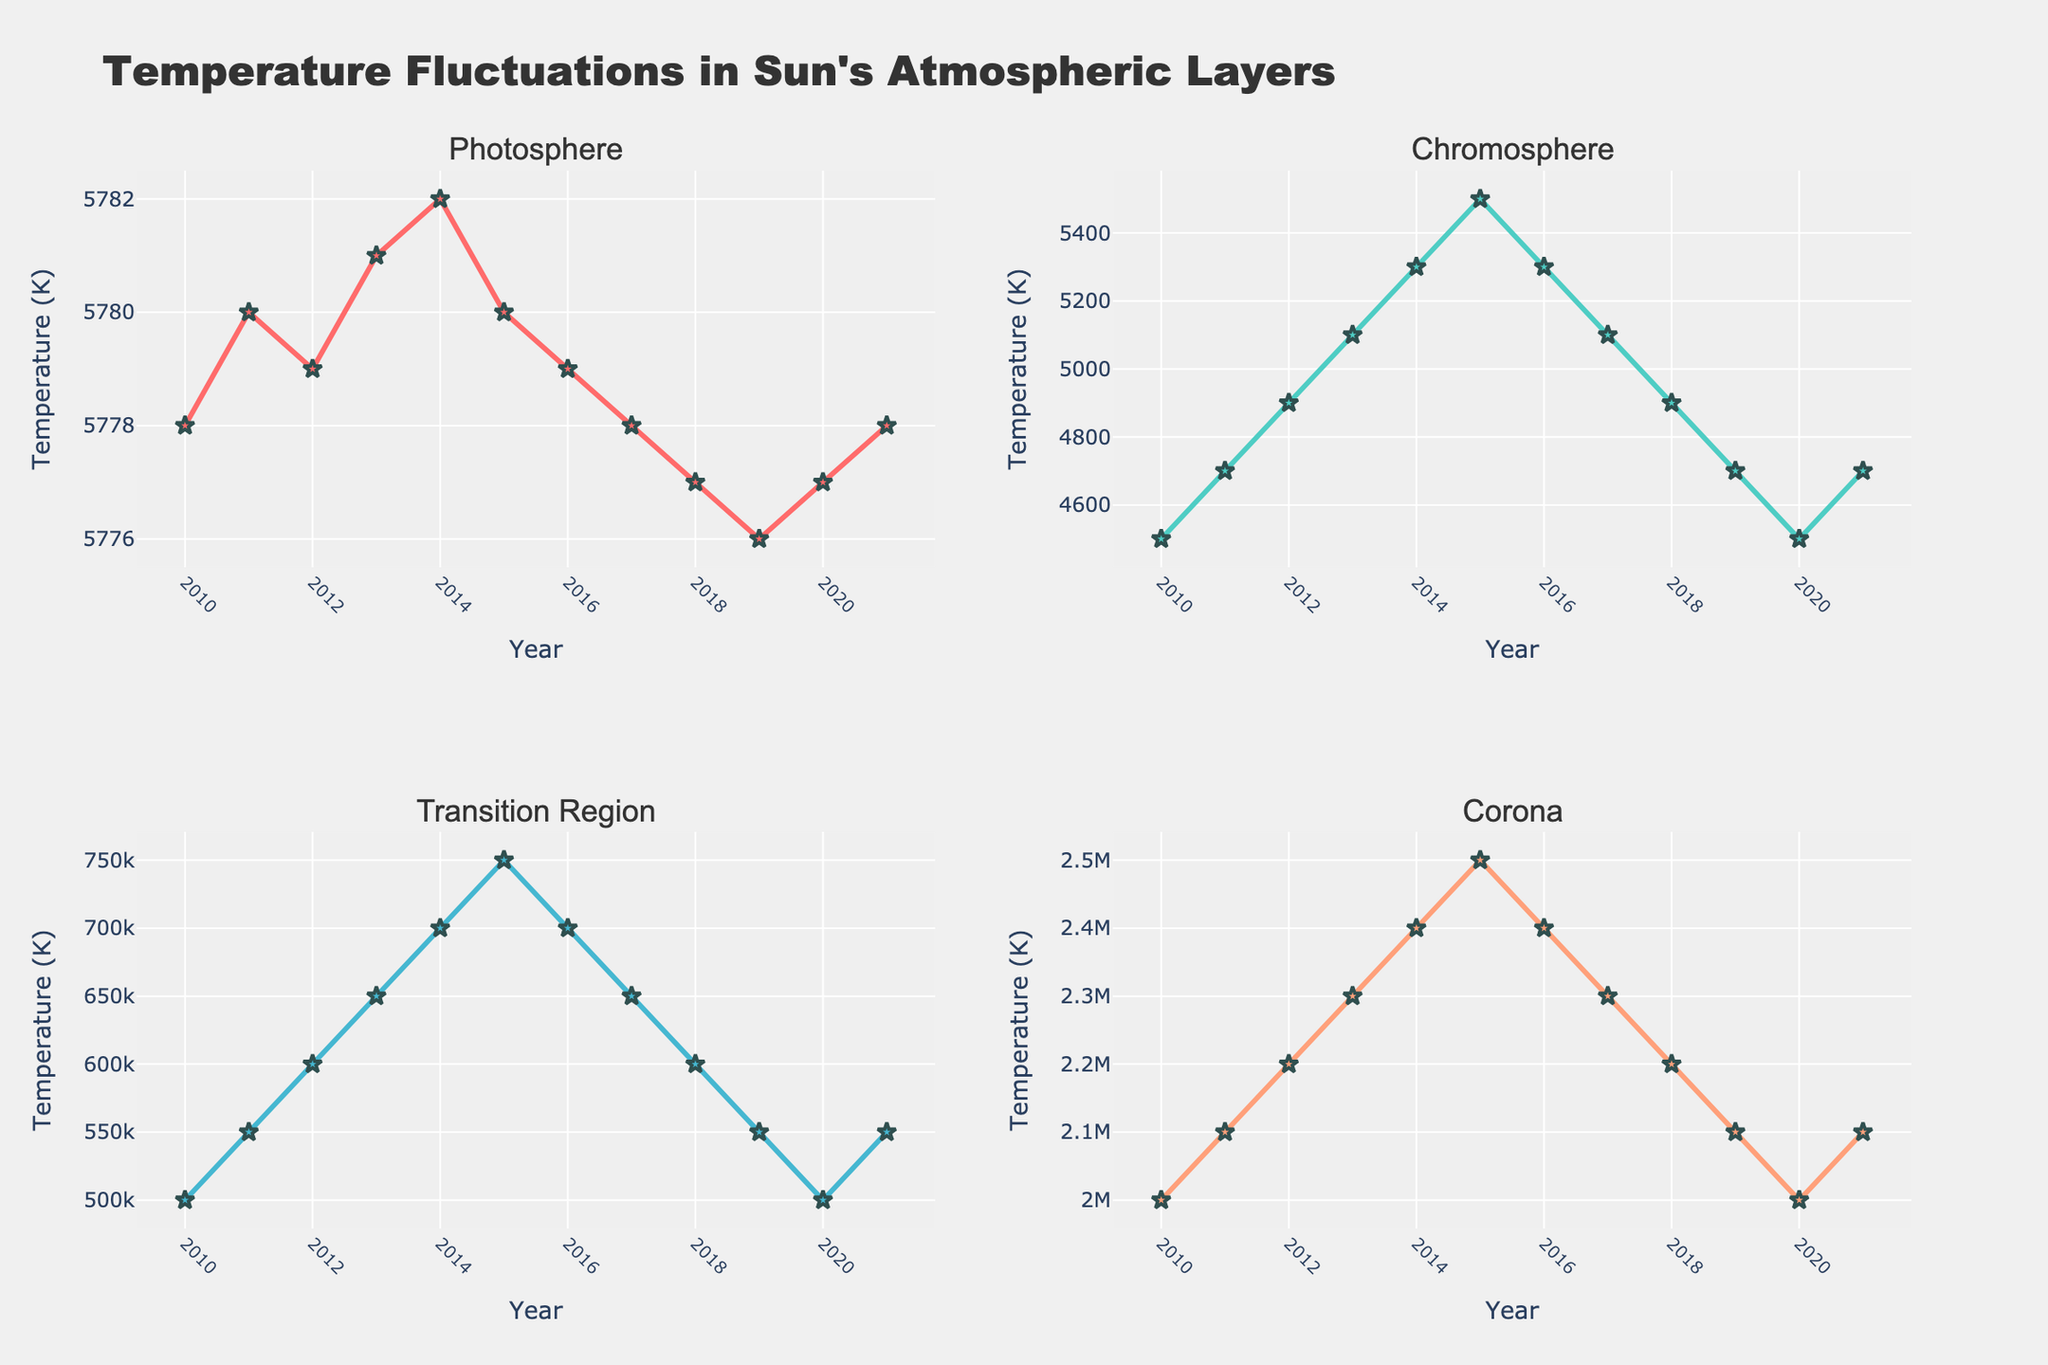what is the title of the figure? The title of the figure can be found at the top. It is written in larger text and serves as the header for the entire figure.
Answer: Temperature Fluctuations in Sun's Atmospheric Layers What is the temperature in the Photosphere in the year 2014? Look at the subplot titled "Photosphere". Find the point on the line marked for 2014. Read the corresponding temperature value.
Answer: 5782 K Which layer shows the highest temperature in the year 2016? Observe all subplots for the year 2016. Compare the temperature values. The highest temperature is in the Corona subplot.
Answer: Corona What is the temperature difference between the Chromosphere and the Transition Region in the year 2020? Locate 2020 in both the Chromosphere and Transition Region subplots. Subtract the Chromosphere temperature from the Transition Region temperature (500000 - 4500).
Answer: 495500 K Which layer has the smallest temperature range over the years? Compare the temperature fluctuations visually across all subplots. The Photosphere appears to have the smallest temperature range.
Answer: Photosphere How does the Corona's temperature change from 2012 to 2018? Check the Corona subplot. Note the temperature for 2012 and 2018. Observe the increase from 2200000 K to 2200000 K.
Answer: It remains constant During which year does the Chromosphere reach its peak temperature? Examine the curve in the Chromosphere subplot. Identify the highest point on the graph and the corresponding year.
Answer: 2015 Compare the temperature trends of the Transition Region and Corona from 2010 to 2014. Observe both the Transition Region and Corona subplots from 2010 to 2014. Both show increasing temperature trends, but the Corona increases consistently while the Transition Region shows a slight delay.
Answer: Both increase, Corona consistently What is the average temperature of the Photosphere over the years? Add the Photosphere temperatures from 2010 to 2021 (sum = 69332). Divide by the number of years (12).
Answer: 5777.67 K How does the temperature in the Chromosphere in 2011 compare to its temperature in 2021? Check the Chromosphere subplot for the values in 2011 and 2021 (4700 K for both years). They are equal.
Answer: They are the same 